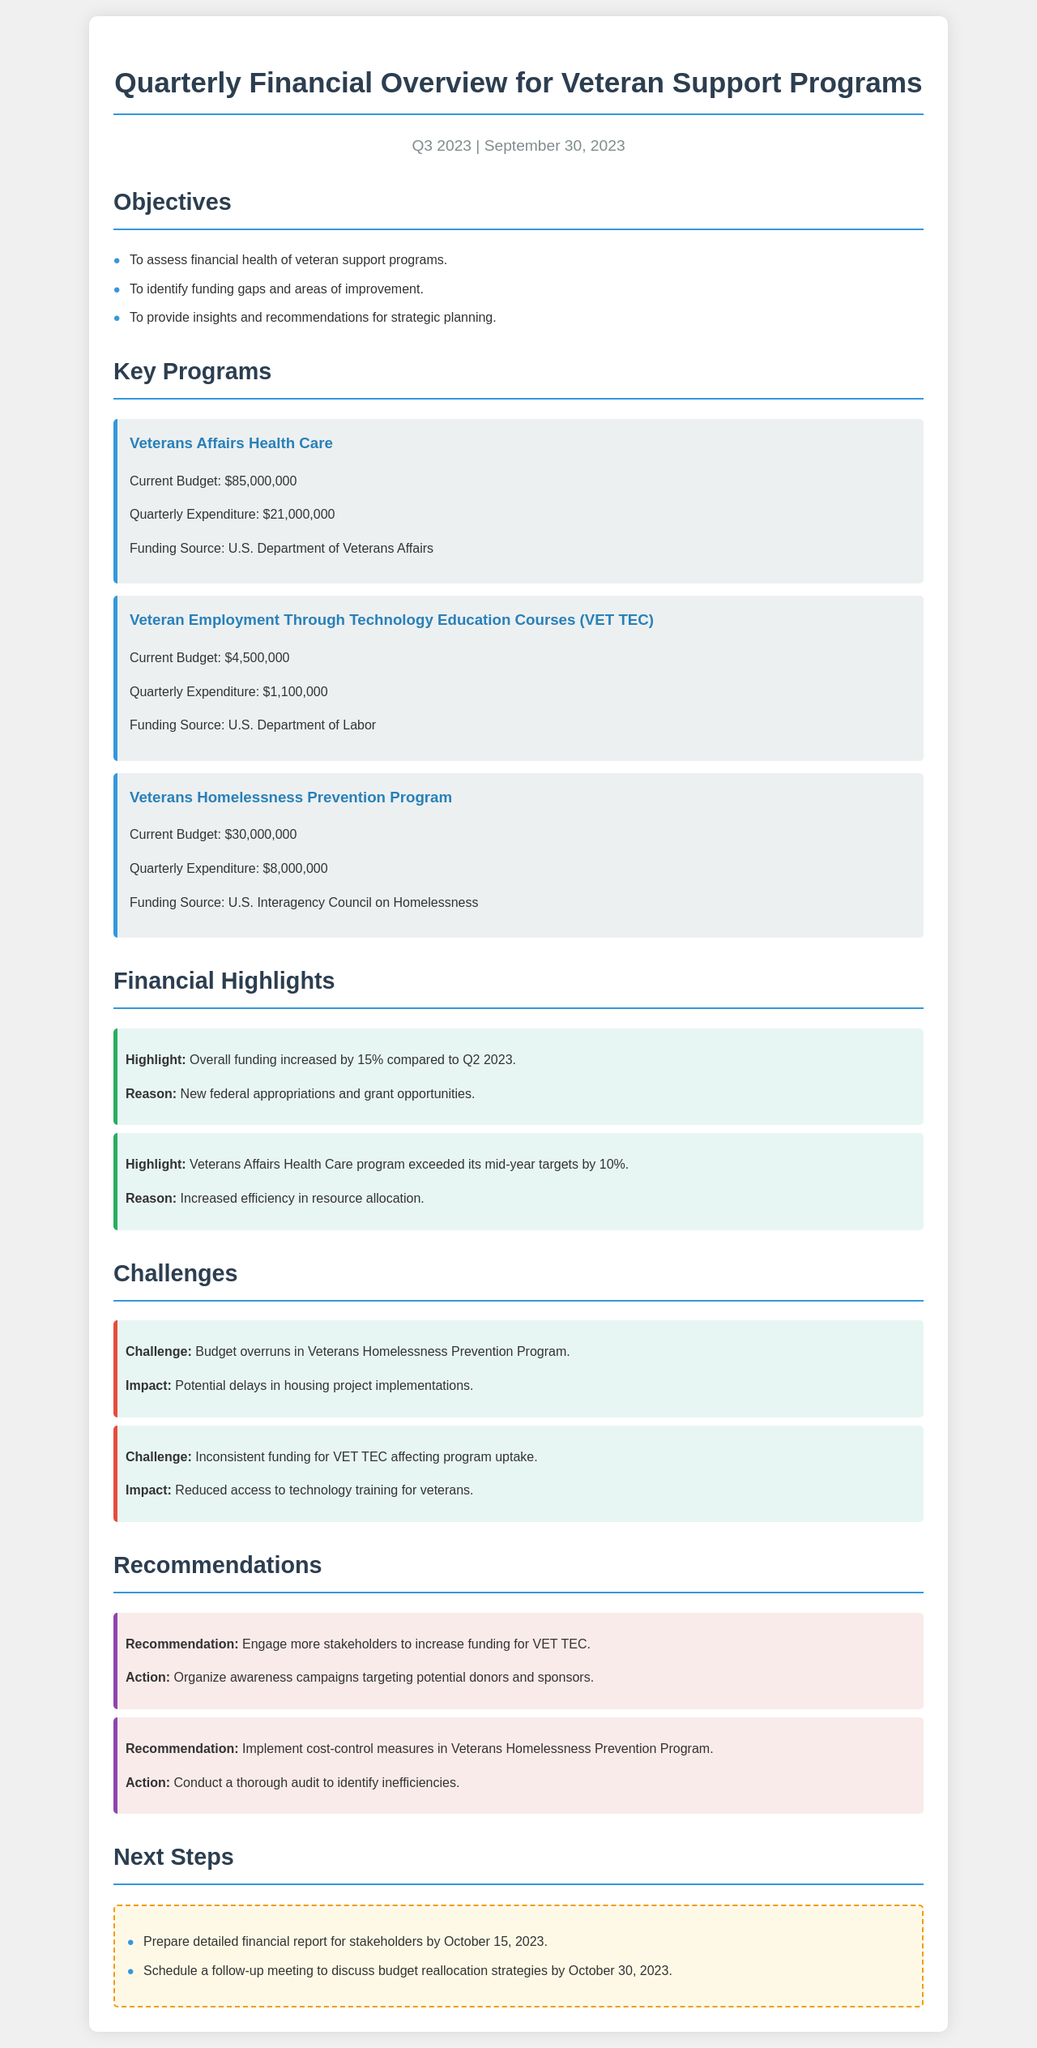What is the total budget for the Veterans Affairs Health Care program? The total budget for the Veterans Affairs Health Care program is specified as $85,000,000.
Answer: $85,000,000 What percentage did overall funding increase compared to Q2 2023? The document states that overall funding increased by 15% compared to Q2 2023.
Answer: 15% What is the total quarterly expenditure for the Veterans Homelessness Prevention Program? The total quarterly expenditure for the Veterans Homelessness Prevention Program is given as $8,000,000.
Answer: $8,000,000 What is the recommended action for the VET TEC program? The document recommends engaging more stakeholders to increase funding for VET TEC and organizing awareness campaigns targeting potential donors and sponsors.
Answer: Organize awareness campaigns What impact does the budget overrun in the Veterans Homelessness Prevention Program have? The document mentions that the budget overruns may lead to potential delays in housing project implementations.
Answer: Potential delays What date is the detailed financial report due? The report is to be prepared by October 15, 2023.
Answer: October 15, 2023 What is the funding source for the VET TEC program? The funding source for the VET TEC program is listed as the U.S. Department of Labor.
Answer: U.S. Department of Labor What challenge is mentioned regarding VET TEC? The document indicates that inconsistent funding for VET TEC is affecting program uptake.
Answer: Inconsistent funding What is the total quarterly expenditure across all key programs? The total quarterly expenditure is calculated as $21,000,000 + $1,100,000 + $8,000,000 = $30,100,000.
Answer: $30,100,000 